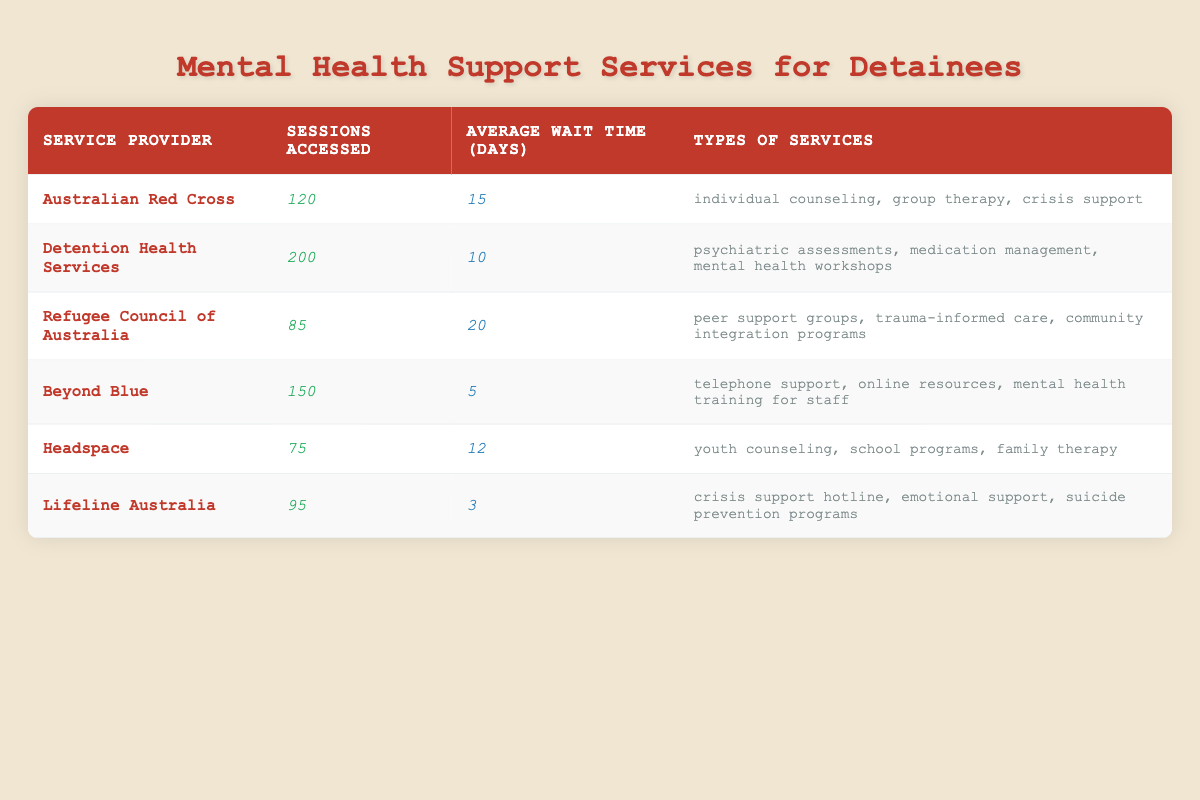What is the service provider with the highest number of sessions accessed? Looking at the "Sessions Accessed" column, "Detention Health Services" has the highest value at 200 sessions.
Answer: Detention Health Services Which service provider has the shortest average wait time? The "Average Wait Time (Days)" column shows that "Lifeline Australia" has the shortest wait time of 3 days.
Answer: Lifeline Australia How many more sessions were accessed through "Beyond Blue" compared to "Headspace"? Subtract the sessions accessed by "Headspace" (75) from those accessed by "Beyond Blue" (150) gives 150 - 75 = 75 more sessions.
Answer: 75 What percentage of sessions accessed were through "Australian Red Cross"? The total sessions accessed are 200 (Detention Health Services) + 120 (Australian Red Cross) + 85 (Refugee Council of Australia) + 150 (Beyond Blue) + 75 (Headspace) + 95 (Lifeline Australia) = 725. The percentage for "Australian Red Cross" is (120 / 725) * 100 = 16.55%.
Answer: 16.55% Is there a service provider that offers only crisis support? Checking the types of services, "Lifeline Australia" only offers a "crisis support hotline" besides other services, but it is not limited to crisis support alone. Therefore, there is no provider that offers solely crisis support.
Answer: No What is the average number of sessions accessed by all providers? The total number of sessions (725) divided by the number of providers (6) gives an average of approximately 120.83 sessions.
Answer: 120.83 Which service provider has the longest average wait time? The "Average Wait Time (Days)" column indicates that "Refugee Council of Australia" has the longest wait time at 20 days.
Answer: Refugee Council of Australia If we add the sessions accessed for "Lifeline Australia" and "Headspace", what is the total? Adding the sessions from both providers gives 95 (Lifeline Australia) + 75 (Headspace) = 170 sessions in total.
Answer: 170 Are there any service providers whose average wait times exceed 15 days? The providers with wait times longer than 15 days are "Refugee Council of Australia" (20 days) and "Australian Red Cross" (15 days), so the answer is yes, as "Refugee Council of Australia" exceeds it.
Answer: Yes Which type of service is offered by the "Refugee Council of Australia"? In the types of services listed, "Refugee Council of Australia" provides "peer support groups, trauma-informed care, community integration programs".
Answer: Peer support groups, trauma-informed care, community integration programs 